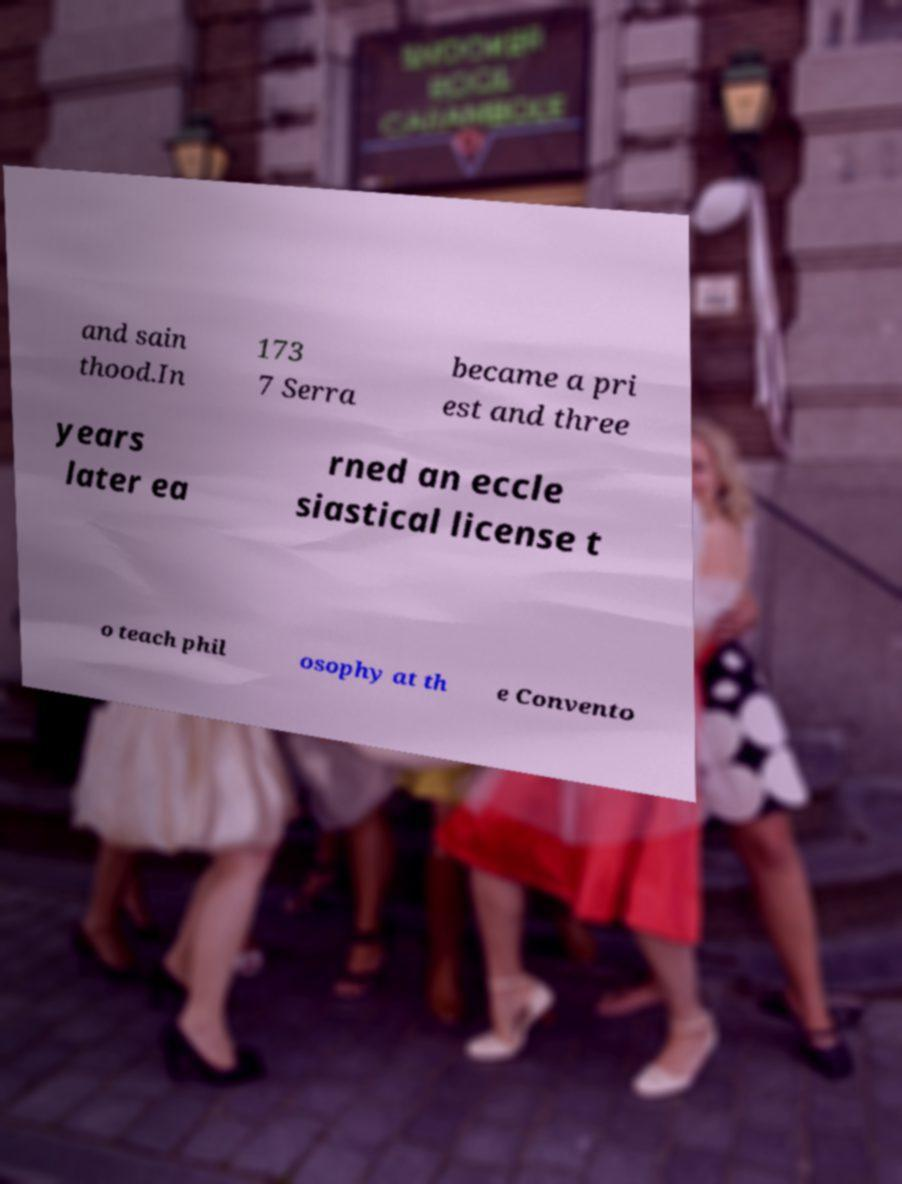Could you extract and type out the text from this image? and sain thood.In 173 7 Serra became a pri est and three years later ea rned an eccle siastical license t o teach phil osophy at th e Convento 